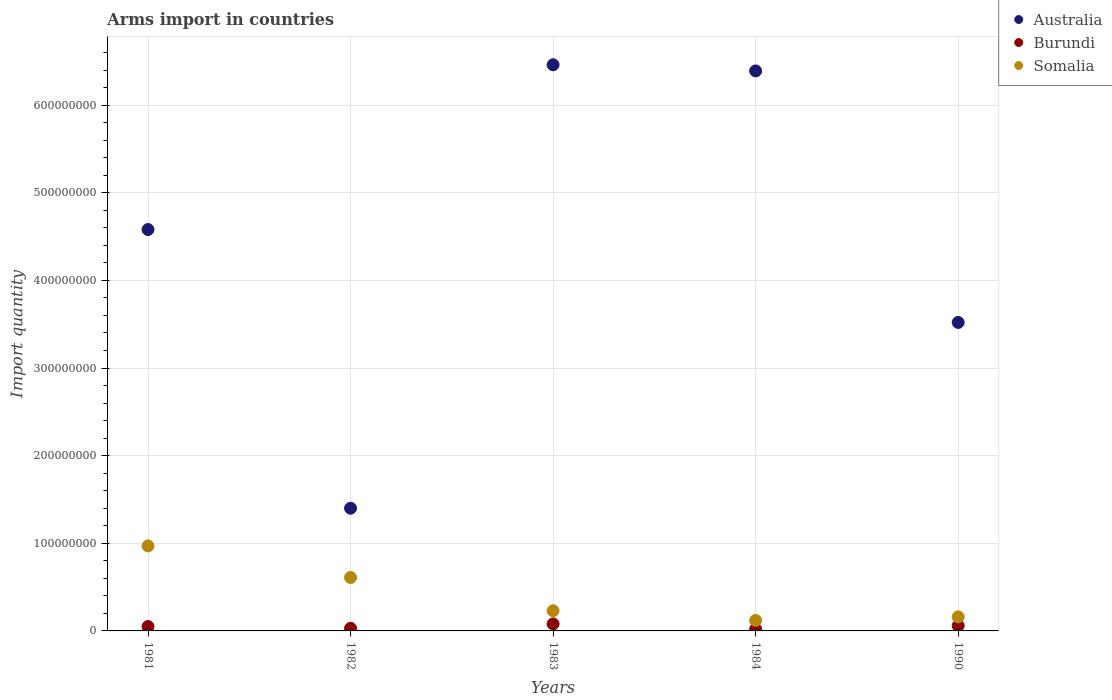Is the number of dotlines equal to the number of legend labels?
Provide a succinct answer. Yes. Across all years, what is the maximum total arms import in Somalia?
Your answer should be compact. 9.70e+07. Across all years, what is the minimum total arms import in Australia?
Ensure brevity in your answer.  1.40e+08. In which year was the total arms import in Australia maximum?
Your answer should be very brief. 1983. In which year was the total arms import in Australia minimum?
Provide a short and direct response. 1982. What is the total total arms import in Burundi in the graph?
Give a very brief answer. 2.40e+07. What is the difference between the total arms import in Burundi in 1984 and the total arms import in Somalia in 1981?
Make the answer very short. -9.50e+07. What is the average total arms import in Burundi per year?
Your answer should be very brief. 4.80e+06. In the year 1984, what is the difference between the total arms import in Burundi and total arms import in Australia?
Give a very brief answer. -6.37e+08. In how many years, is the total arms import in Somalia greater than 120000000?
Give a very brief answer. 0. What is the ratio of the total arms import in Somalia in 1981 to that in 1990?
Offer a very short reply. 6.06. Is the difference between the total arms import in Burundi in 1984 and 1990 greater than the difference between the total arms import in Australia in 1984 and 1990?
Offer a very short reply. No. Is the sum of the total arms import in Burundi in 1984 and 1990 greater than the maximum total arms import in Somalia across all years?
Keep it short and to the point. No. Is it the case that in every year, the sum of the total arms import in Australia and total arms import in Burundi  is greater than the total arms import in Somalia?
Offer a very short reply. Yes. Is the total arms import in Burundi strictly greater than the total arms import in Somalia over the years?
Your answer should be very brief. No. Does the graph contain any zero values?
Give a very brief answer. No. Where does the legend appear in the graph?
Keep it short and to the point. Top right. What is the title of the graph?
Your answer should be very brief. Arms import in countries. What is the label or title of the X-axis?
Keep it short and to the point. Years. What is the label or title of the Y-axis?
Keep it short and to the point. Import quantity. What is the Import quantity in Australia in 1981?
Make the answer very short. 4.58e+08. What is the Import quantity in Somalia in 1981?
Your answer should be very brief. 9.70e+07. What is the Import quantity of Australia in 1982?
Provide a short and direct response. 1.40e+08. What is the Import quantity of Burundi in 1982?
Provide a succinct answer. 3.00e+06. What is the Import quantity of Somalia in 1982?
Keep it short and to the point. 6.10e+07. What is the Import quantity in Australia in 1983?
Provide a short and direct response. 6.46e+08. What is the Import quantity in Burundi in 1983?
Offer a very short reply. 8.00e+06. What is the Import quantity of Somalia in 1983?
Ensure brevity in your answer.  2.30e+07. What is the Import quantity of Australia in 1984?
Provide a succinct answer. 6.39e+08. What is the Import quantity in Somalia in 1984?
Make the answer very short. 1.20e+07. What is the Import quantity of Australia in 1990?
Offer a terse response. 3.52e+08. What is the Import quantity in Somalia in 1990?
Your answer should be very brief. 1.60e+07. Across all years, what is the maximum Import quantity in Australia?
Your answer should be compact. 6.46e+08. Across all years, what is the maximum Import quantity of Burundi?
Give a very brief answer. 8.00e+06. Across all years, what is the maximum Import quantity in Somalia?
Provide a succinct answer. 9.70e+07. Across all years, what is the minimum Import quantity of Australia?
Provide a short and direct response. 1.40e+08. Across all years, what is the minimum Import quantity in Burundi?
Give a very brief answer. 2.00e+06. What is the total Import quantity in Australia in the graph?
Provide a succinct answer. 2.24e+09. What is the total Import quantity in Burundi in the graph?
Your response must be concise. 2.40e+07. What is the total Import quantity in Somalia in the graph?
Offer a very short reply. 2.09e+08. What is the difference between the Import quantity of Australia in 1981 and that in 1982?
Your response must be concise. 3.18e+08. What is the difference between the Import quantity in Burundi in 1981 and that in 1982?
Your response must be concise. 2.00e+06. What is the difference between the Import quantity in Somalia in 1981 and that in 1982?
Keep it short and to the point. 3.60e+07. What is the difference between the Import quantity of Australia in 1981 and that in 1983?
Your answer should be compact. -1.88e+08. What is the difference between the Import quantity of Somalia in 1981 and that in 1983?
Your answer should be compact. 7.40e+07. What is the difference between the Import quantity in Australia in 1981 and that in 1984?
Your answer should be compact. -1.81e+08. What is the difference between the Import quantity in Somalia in 1981 and that in 1984?
Give a very brief answer. 8.50e+07. What is the difference between the Import quantity of Australia in 1981 and that in 1990?
Your response must be concise. 1.06e+08. What is the difference between the Import quantity of Somalia in 1981 and that in 1990?
Keep it short and to the point. 8.10e+07. What is the difference between the Import quantity in Australia in 1982 and that in 1983?
Provide a succinct answer. -5.06e+08. What is the difference between the Import quantity of Burundi in 1982 and that in 1983?
Make the answer very short. -5.00e+06. What is the difference between the Import quantity of Somalia in 1982 and that in 1983?
Make the answer very short. 3.80e+07. What is the difference between the Import quantity of Australia in 1982 and that in 1984?
Offer a terse response. -4.99e+08. What is the difference between the Import quantity of Somalia in 1982 and that in 1984?
Provide a short and direct response. 4.90e+07. What is the difference between the Import quantity of Australia in 1982 and that in 1990?
Give a very brief answer. -2.12e+08. What is the difference between the Import quantity in Somalia in 1982 and that in 1990?
Give a very brief answer. 4.50e+07. What is the difference between the Import quantity of Australia in 1983 and that in 1984?
Offer a terse response. 7.00e+06. What is the difference between the Import quantity of Burundi in 1983 and that in 1984?
Your response must be concise. 6.00e+06. What is the difference between the Import quantity of Somalia in 1983 and that in 1984?
Offer a terse response. 1.10e+07. What is the difference between the Import quantity of Australia in 1983 and that in 1990?
Give a very brief answer. 2.94e+08. What is the difference between the Import quantity in Burundi in 1983 and that in 1990?
Your response must be concise. 2.00e+06. What is the difference between the Import quantity in Somalia in 1983 and that in 1990?
Your response must be concise. 7.00e+06. What is the difference between the Import quantity in Australia in 1984 and that in 1990?
Your answer should be compact. 2.87e+08. What is the difference between the Import quantity of Burundi in 1984 and that in 1990?
Ensure brevity in your answer.  -4.00e+06. What is the difference between the Import quantity of Australia in 1981 and the Import quantity of Burundi in 1982?
Offer a very short reply. 4.55e+08. What is the difference between the Import quantity in Australia in 1981 and the Import quantity in Somalia in 1982?
Offer a terse response. 3.97e+08. What is the difference between the Import quantity in Burundi in 1981 and the Import quantity in Somalia in 1982?
Your response must be concise. -5.60e+07. What is the difference between the Import quantity of Australia in 1981 and the Import quantity of Burundi in 1983?
Give a very brief answer. 4.50e+08. What is the difference between the Import quantity in Australia in 1981 and the Import quantity in Somalia in 1983?
Your answer should be compact. 4.35e+08. What is the difference between the Import quantity in Burundi in 1981 and the Import quantity in Somalia in 1983?
Provide a succinct answer. -1.80e+07. What is the difference between the Import quantity of Australia in 1981 and the Import quantity of Burundi in 1984?
Keep it short and to the point. 4.56e+08. What is the difference between the Import quantity of Australia in 1981 and the Import quantity of Somalia in 1984?
Give a very brief answer. 4.46e+08. What is the difference between the Import quantity in Burundi in 1981 and the Import quantity in Somalia in 1984?
Offer a very short reply. -7.00e+06. What is the difference between the Import quantity in Australia in 1981 and the Import quantity in Burundi in 1990?
Offer a terse response. 4.52e+08. What is the difference between the Import quantity in Australia in 1981 and the Import quantity in Somalia in 1990?
Offer a terse response. 4.42e+08. What is the difference between the Import quantity in Burundi in 1981 and the Import quantity in Somalia in 1990?
Offer a terse response. -1.10e+07. What is the difference between the Import quantity of Australia in 1982 and the Import quantity of Burundi in 1983?
Make the answer very short. 1.32e+08. What is the difference between the Import quantity of Australia in 1982 and the Import quantity of Somalia in 1983?
Ensure brevity in your answer.  1.17e+08. What is the difference between the Import quantity of Burundi in 1982 and the Import quantity of Somalia in 1983?
Keep it short and to the point. -2.00e+07. What is the difference between the Import quantity of Australia in 1982 and the Import quantity of Burundi in 1984?
Offer a very short reply. 1.38e+08. What is the difference between the Import quantity in Australia in 1982 and the Import quantity in Somalia in 1984?
Provide a short and direct response. 1.28e+08. What is the difference between the Import quantity in Burundi in 1982 and the Import quantity in Somalia in 1984?
Offer a very short reply. -9.00e+06. What is the difference between the Import quantity in Australia in 1982 and the Import quantity in Burundi in 1990?
Keep it short and to the point. 1.34e+08. What is the difference between the Import quantity in Australia in 1982 and the Import quantity in Somalia in 1990?
Provide a succinct answer. 1.24e+08. What is the difference between the Import quantity of Burundi in 1982 and the Import quantity of Somalia in 1990?
Keep it short and to the point. -1.30e+07. What is the difference between the Import quantity in Australia in 1983 and the Import quantity in Burundi in 1984?
Offer a terse response. 6.44e+08. What is the difference between the Import quantity of Australia in 1983 and the Import quantity of Somalia in 1984?
Give a very brief answer. 6.34e+08. What is the difference between the Import quantity of Burundi in 1983 and the Import quantity of Somalia in 1984?
Your response must be concise. -4.00e+06. What is the difference between the Import quantity in Australia in 1983 and the Import quantity in Burundi in 1990?
Provide a short and direct response. 6.40e+08. What is the difference between the Import quantity in Australia in 1983 and the Import quantity in Somalia in 1990?
Your answer should be compact. 6.30e+08. What is the difference between the Import quantity of Burundi in 1983 and the Import quantity of Somalia in 1990?
Provide a succinct answer. -8.00e+06. What is the difference between the Import quantity in Australia in 1984 and the Import quantity in Burundi in 1990?
Provide a short and direct response. 6.33e+08. What is the difference between the Import quantity in Australia in 1984 and the Import quantity in Somalia in 1990?
Make the answer very short. 6.23e+08. What is the difference between the Import quantity in Burundi in 1984 and the Import quantity in Somalia in 1990?
Your answer should be compact. -1.40e+07. What is the average Import quantity in Australia per year?
Your answer should be very brief. 4.47e+08. What is the average Import quantity of Burundi per year?
Provide a short and direct response. 4.80e+06. What is the average Import quantity of Somalia per year?
Your response must be concise. 4.18e+07. In the year 1981, what is the difference between the Import quantity in Australia and Import quantity in Burundi?
Your answer should be very brief. 4.53e+08. In the year 1981, what is the difference between the Import quantity in Australia and Import quantity in Somalia?
Provide a succinct answer. 3.61e+08. In the year 1981, what is the difference between the Import quantity in Burundi and Import quantity in Somalia?
Ensure brevity in your answer.  -9.20e+07. In the year 1982, what is the difference between the Import quantity in Australia and Import quantity in Burundi?
Ensure brevity in your answer.  1.37e+08. In the year 1982, what is the difference between the Import quantity in Australia and Import quantity in Somalia?
Your response must be concise. 7.90e+07. In the year 1982, what is the difference between the Import quantity of Burundi and Import quantity of Somalia?
Give a very brief answer. -5.80e+07. In the year 1983, what is the difference between the Import quantity in Australia and Import quantity in Burundi?
Provide a succinct answer. 6.38e+08. In the year 1983, what is the difference between the Import quantity of Australia and Import quantity of Somalia?
Offer a terse response. 6.23e+08. In the year 1983, what is the difference between the Import quantity in Burundi and Import quantity in Somalia?
Provide a succinct answer. -1.50e+07. In the year 1984, what is the difference between the Import quantity in Australia and Import quantity in Burundi?
Make the answer very short. 6.37e+08. In the year 1984, what is the difference between the Import quantity in Australia and Import quantity in Somalia?
Offer a terse response. 6.27e+08. In the year 1984, what is the difference between the Import quantity in Burundi and Import quantity in Somalia?
Your response must be concise. -1.00e+07. In the year 1990, what is the difference between the Import quantity of Australia and Import quantity of Burundi?
Ensure brevity in your answer.  3.46e+08. In the year 1990, what is the difference between the Import quantity of Australia and Import quantity of Somalia?
Offer a terse response. 3.36e+08. In the year 1990, what is the difference between the Import quantity of Burundi and Import quantity of Somalia?
Your answer should be compact. -1.00e+07. What is the ratio of the Import quantity of Australia in 1981 to that in 1982?
Provide a short and direct response. 3.27. What is the ratio of the Import quantity in Burundi in 1981 to that in 1982?
Your response must be concise. 1.67. What is the ratio of the Import quantity of Somalia in 1981 to that in 1982?
Ensure brevity in your answer.  1.59. What is the ratio of the Import quantity in Australia in 1981 to that in 1983?
Offer a very short reply. 0.71. What is the ratio of the Import quantity in Burundi in 1981 to that in 1983?
Make the answer very short. 0.62. What is the ratio of the Import quantity in Somalia in 1981 to that in 1983?
Provide a succinct answer. 4.22. What is the ratio of the Import quantity of Australia in 1981 to that in 1984?
Make the answer very short. 0.72. What is the ratio of the Import quantity of Burundi in 1981 to that in 1984?
Your answer should be compact. 2.5. What is the ratio of the Import quantity of Somalia in 1981 to that in 1984?
Ensure brevity in your answer.  8.08. What is the ratio of the Import quantity in Australia in 1981 to that in 1990?
Offer a very short reply. 1.3. What is the ratio of the Import quantity in Somalia in 1981 to that in 1990?
Ensure brevity in your answer.  6.06. What is the ratio of the Import quantity in Australia in 1982 to that in 1983?
Your answer should be very brief. 0.22. What is the ratio of the Import quantity in Burundi in 1982 to that in 1983?
Your answer should be compact. 0.38. What is the ratio of the Import quantity in Somalia in 1982 to that in 1983?
Your response must be concise. 2.65. What is the ratio of the Import quantity of Australia in 1982 to that in 1984?
Ensure brevity in your answer.  0.22. What is the ratio of the Import quantity in Burundi in 1982 to that in 1984?
Keep it short and to the point. 1.5. What is the ratio of the Import quantity in Somalia in 1982 to that in 1984?
Make the answer very short. 5.08. What is the ratio of the Import quantity in Australia in 1982 to that in 1990?
Ensure brevity in your answer.  0.4. What is the ratio of the Import quantity of Burundi in 1982 to that in 1990?
Your answer should be very brief. 0.5. What is the ratio of the Import quantity of Somalia in 1982 to that in 1990?
Offer a terse response. 3.81. What is the ratio of the Import quantity of Burundi in 1983 to that in 1984?
Ensure brevity in your answer.  4. What is the ratio of the Import quantity in Somalia in 1983 to that in 1984?
Your answer should be compact. 1.92. What is the ratio of the Import quantity of Australia in 1983 to that in 1990?
Your response must be concise. 1.84. What is the ratio of the Import quantity in Somalia in 1983 to that in 1990?
Provide a short and direct response. 1.44. What is the ratio of the Import quantity of Australia in 1984 to that in 1990?
Offer a terse response. 1.82. What is the difference between the highest and the second highest Import quantity in Australia?
Give a very brief answer. 7.00e+06. What is the difference between the highest and the second highest Import quantity in Burundi?
Your answer should be compact. 2.00e+06. What is the difference between the highest and the second highest Import quantity in Somalia?
Keep it short and to the point. 3.60e+07. What is the difference between the highest and the lowest Import quantity of Australia?
Give a very brief answer. 5.06e+08. What is the difference between the highest and the lowest Import quantity of Somalia?
Offer a terse response. 8.50e+07. 